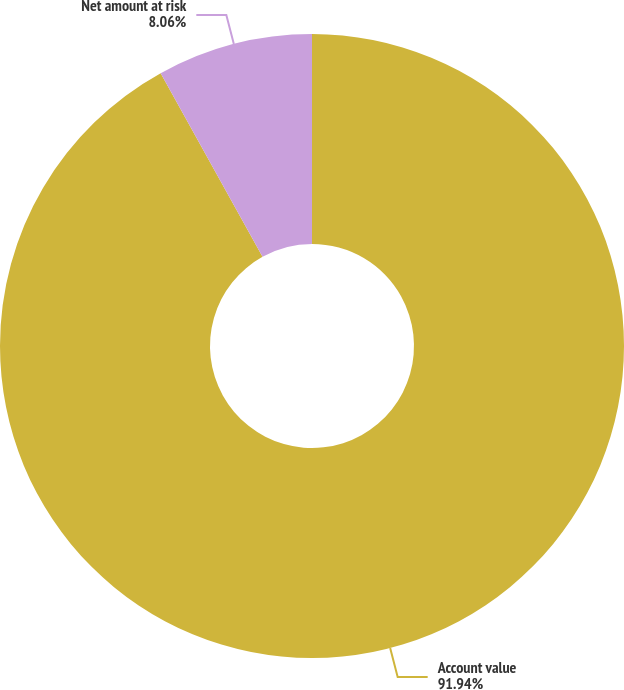Convert chart. <chart><loc_0><loc_0><loc_500><loc_500><pie_chart><fcel>Account value<fcel>Net amount at risk<nl><fcel>91.94%<fcel>8.06%<nl></chart> 